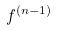Convert formula to latex. <formula><loc_0><loc_0><loc_500><loc_500>f ^ { ( n - 1 ) }</formula> 